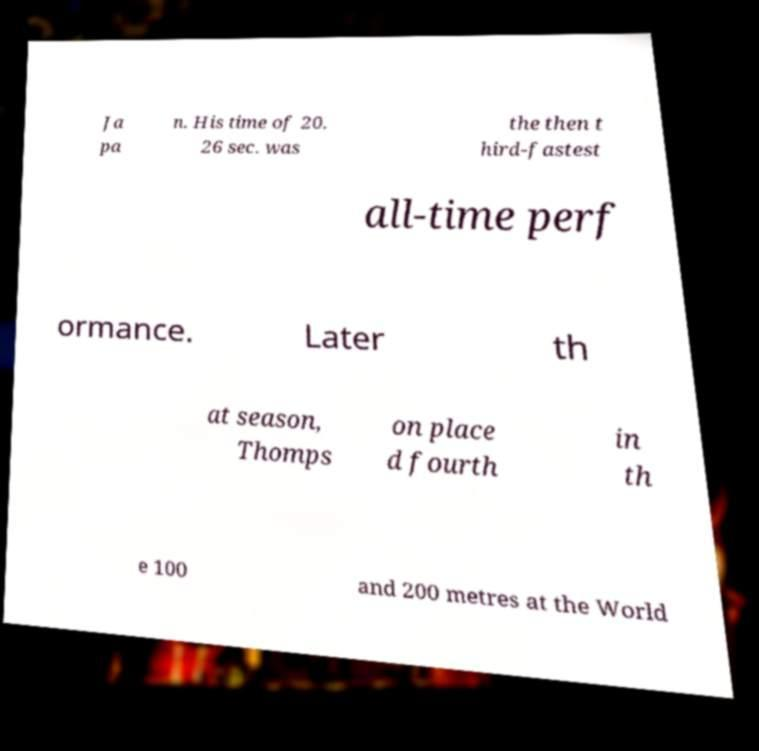Please identify and transcribe the text found in this image. Ja pa n. His time of 20. 26 sec. was the then t hird-fastest all-time perf ormance. Later th at season, Thomps on place d fourth in th e 100 and 200 metres at the World 